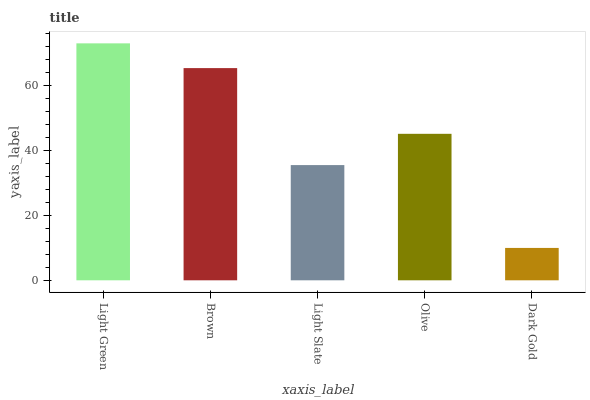Is Dark Gold the minimum?
Answer yes or no. Yes. Is Light Green the maximum?
Answer yes or no. Yes. Is Brown the minimum?
Answer yes or no. No. Is Brown the maximum?
Answer yes or no. No. Is Light Green greater than Brown?
Answer yes or no. Yes. Is Brown less than Light Green?
Answer yes or no. Yes. Is Brown greater than Light Green?
Answer yes or no. No. Is Light Green less than Brown?
Answer yes or no. No. Is Olive the high median?
Answer yes or no. Yes. Is Olive the low median?
Answer yes or no. Yes. Is Brown the high median?
Answer yes or no. No. Is Brown the low median?
Answer yes or no. No. 